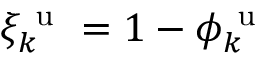Convert formula to latex. <formula><loc_0><loc_0><loc_500><loc_500>\xi _ { k } ^ { u } = 1 - \phi _ { k } ^ { u }</formula> 